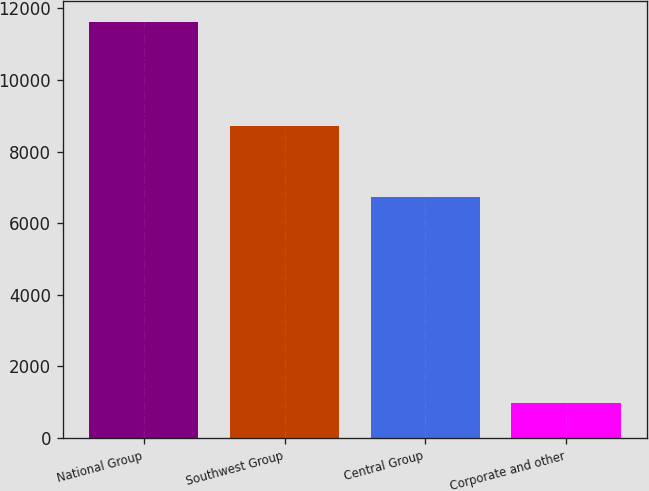Convert chart. <chart><loc_0><loc_0><loc_500><loc_500><bar_chart><fcel>National Group<fcel>Southwest Group<fcel>Central Group<fcel>Corporate and other<nl><fcel>11624<fcel>8700<fcel>6727<fcel>984<nl></chart> 